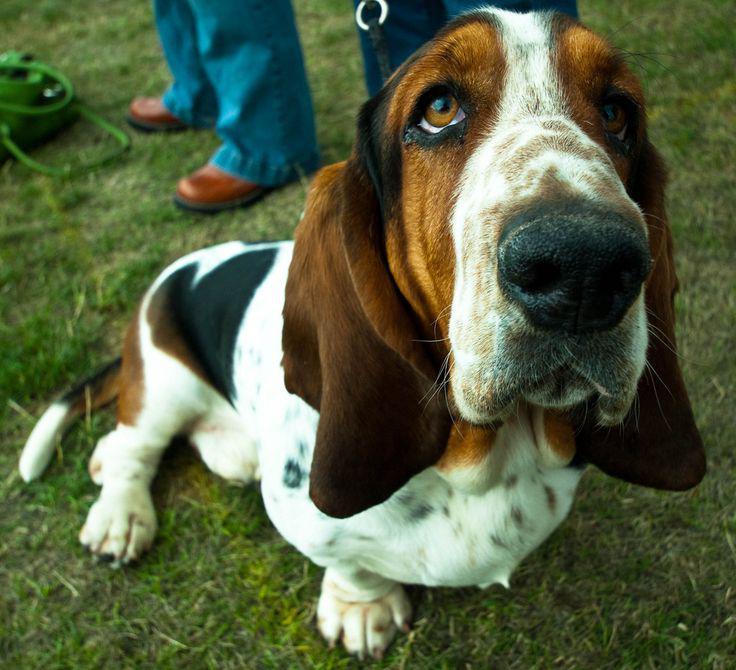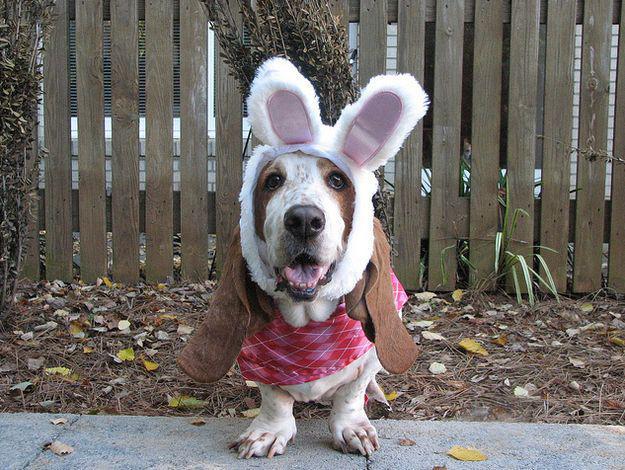The first image is the image on the left, the second image is the image on the right. For the images shown, is this caption "there is only one dog in the image on the left side and it is not wearing bunny ears." true? Answer yes or no. Yes. The first image is the image on the left, the second image is the image on the right. Assess this claim about the two images: "A real basset hound is wearing rabbit hears.". Correct or not? Answer yes or no. Yes. 